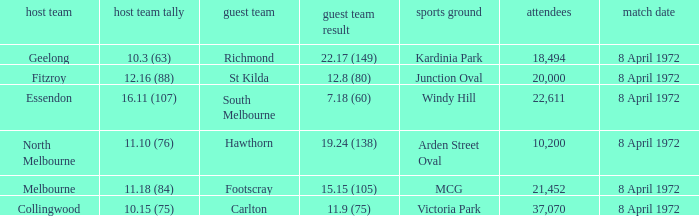Which Venue has a Home team of geelong? Kardinia Park. 